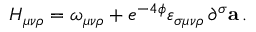Convert formula to latex. <formula><loc_0><loc_0><loc_500><loc_500>H _ { \mu \nu \rho } = \omega _ { \mu \nu \rho } + e ^ { - 4 \phi } \varepsilon _ { \sigma \mu \nu \rho } \, \partial ^ { \sigma } { a } \, .</formula> 